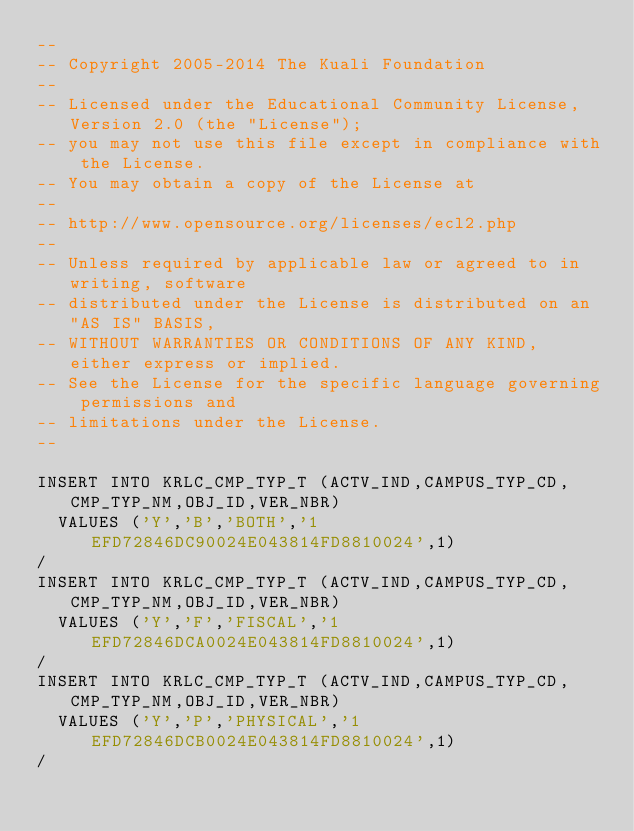<code> <loc_0><loc_0><loc_500><loc_500><_SQL_>--
-- Copyright 2005-2014 The Kuali Foundation
--
-- Licensed under the Educational Community License, Version 2.0 (the "License");
-- you may not use this file except in compliance with the License.
-- You may obtain a copy of the License at
--
-- http://www.opensource.org/licenses/ecl2.php
--
-- Unless required by applicable law or agreed to in writing, software
-- distributed under the License is distributed on an "AS IS" BASIS,
-- WITHOUT WARRANTIES OR CONDITIONS OF ANY KIND, either express or implied.
-- See the License for the specific language governing permissions and
-- limitations under the License.
--

INSERT INTO KRLC_CMP_TYP_T (ACTV_IND,CAMPUS_TYP_CD,CMP_TYP_NM,OBJ_ID,VER_NBR)
  VALUES ('Y','B','BOTH','1EFD72846DC90024E043814FD8810024',1)
/
INSERT INTO KRLC_CMP_TYP_T (ACTV_IND,CAMPUS_TYP_CD,CMP_TYP_NM,OBJ_ID,VER_NBR)
  VALUES ('Y','F','FISCAL','1EFD72846DCA0024E043814FD8810024',1)
/
INSERT INTO KRLC_CMP_TYP_T (ACTV_IND,CAMPUS_TYP_CD,CMP_TYP_NM,OBJ_ID,VER_NBR)
  VALUES ('Y','P','PHYSICAL','1EFD72846DCB0024E043814FD8810024',1)
/
</code> 